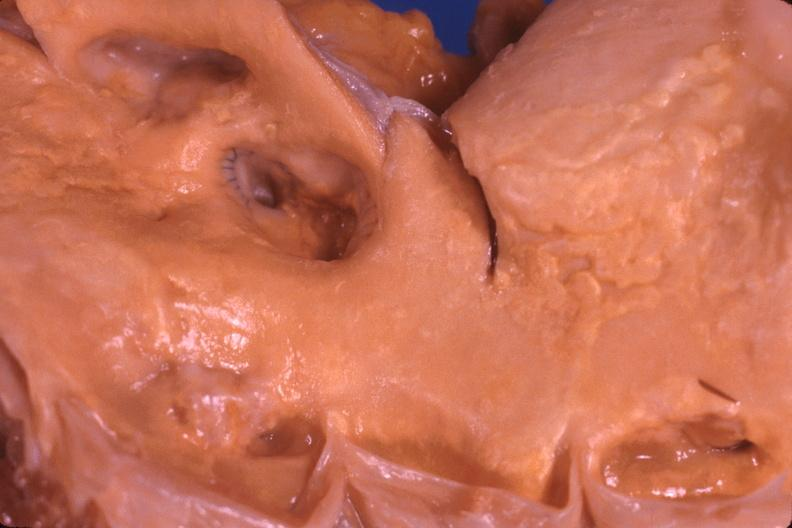s cardiovascular present?
Answer the question using a single word or phrase. Yes 